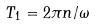<formula> <loc_0><loc_0><loc_500><loc_500>T _ { 1 } = 2 \pi n / \omega</formula> 